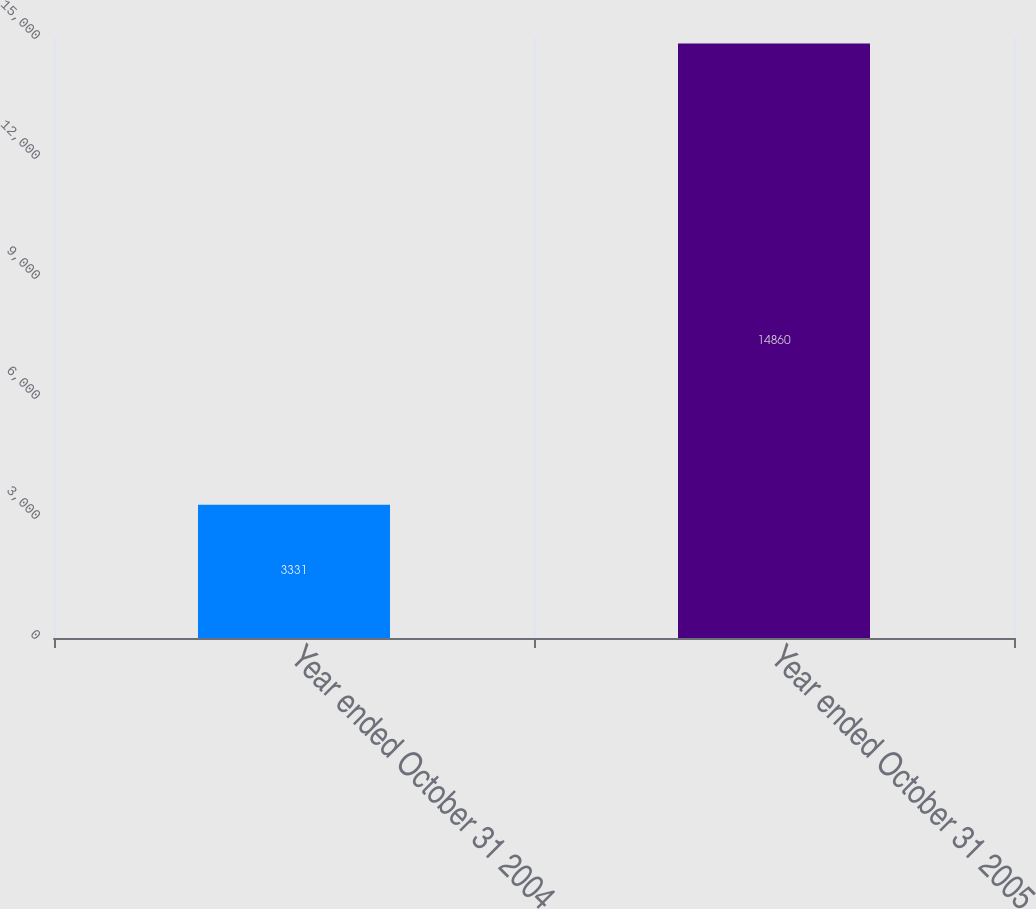Convert chart to OTSL. <chart><loc_0><loc_0><loc_500><loc_500><bar_chart><fcel>Year ended October 31 2004<fcel>Year ended October 31 2005<nl><fcel>3331<fcel>14860<nl></chart> 